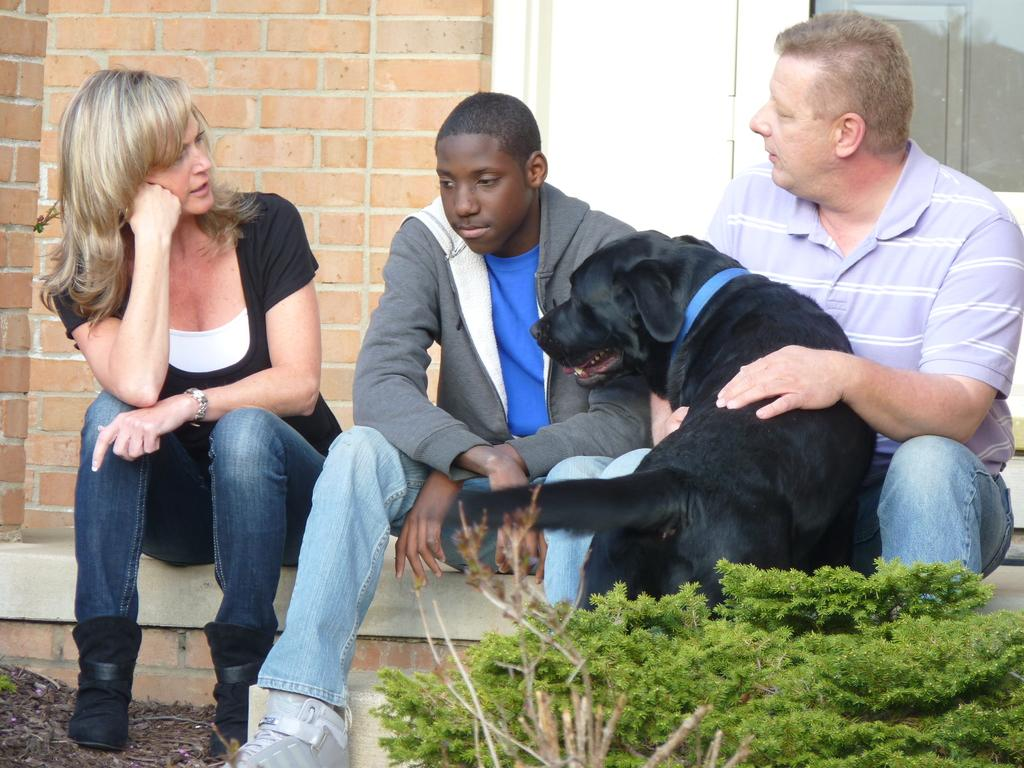How many individuals are present in the image? There are three people in the image. What type of animal is with the people? There is a dog with the people. What is located in front of the people? There is a plant in front of the people. What can be seen in the background of the image? There is a wall in the background of the image. What type of battle is taking place in the image? There is no battle present in the image; it features three people, a dog, a plant, and a wall in the background. How many frogs can be seen in the image? There are no frogs present in the image. 